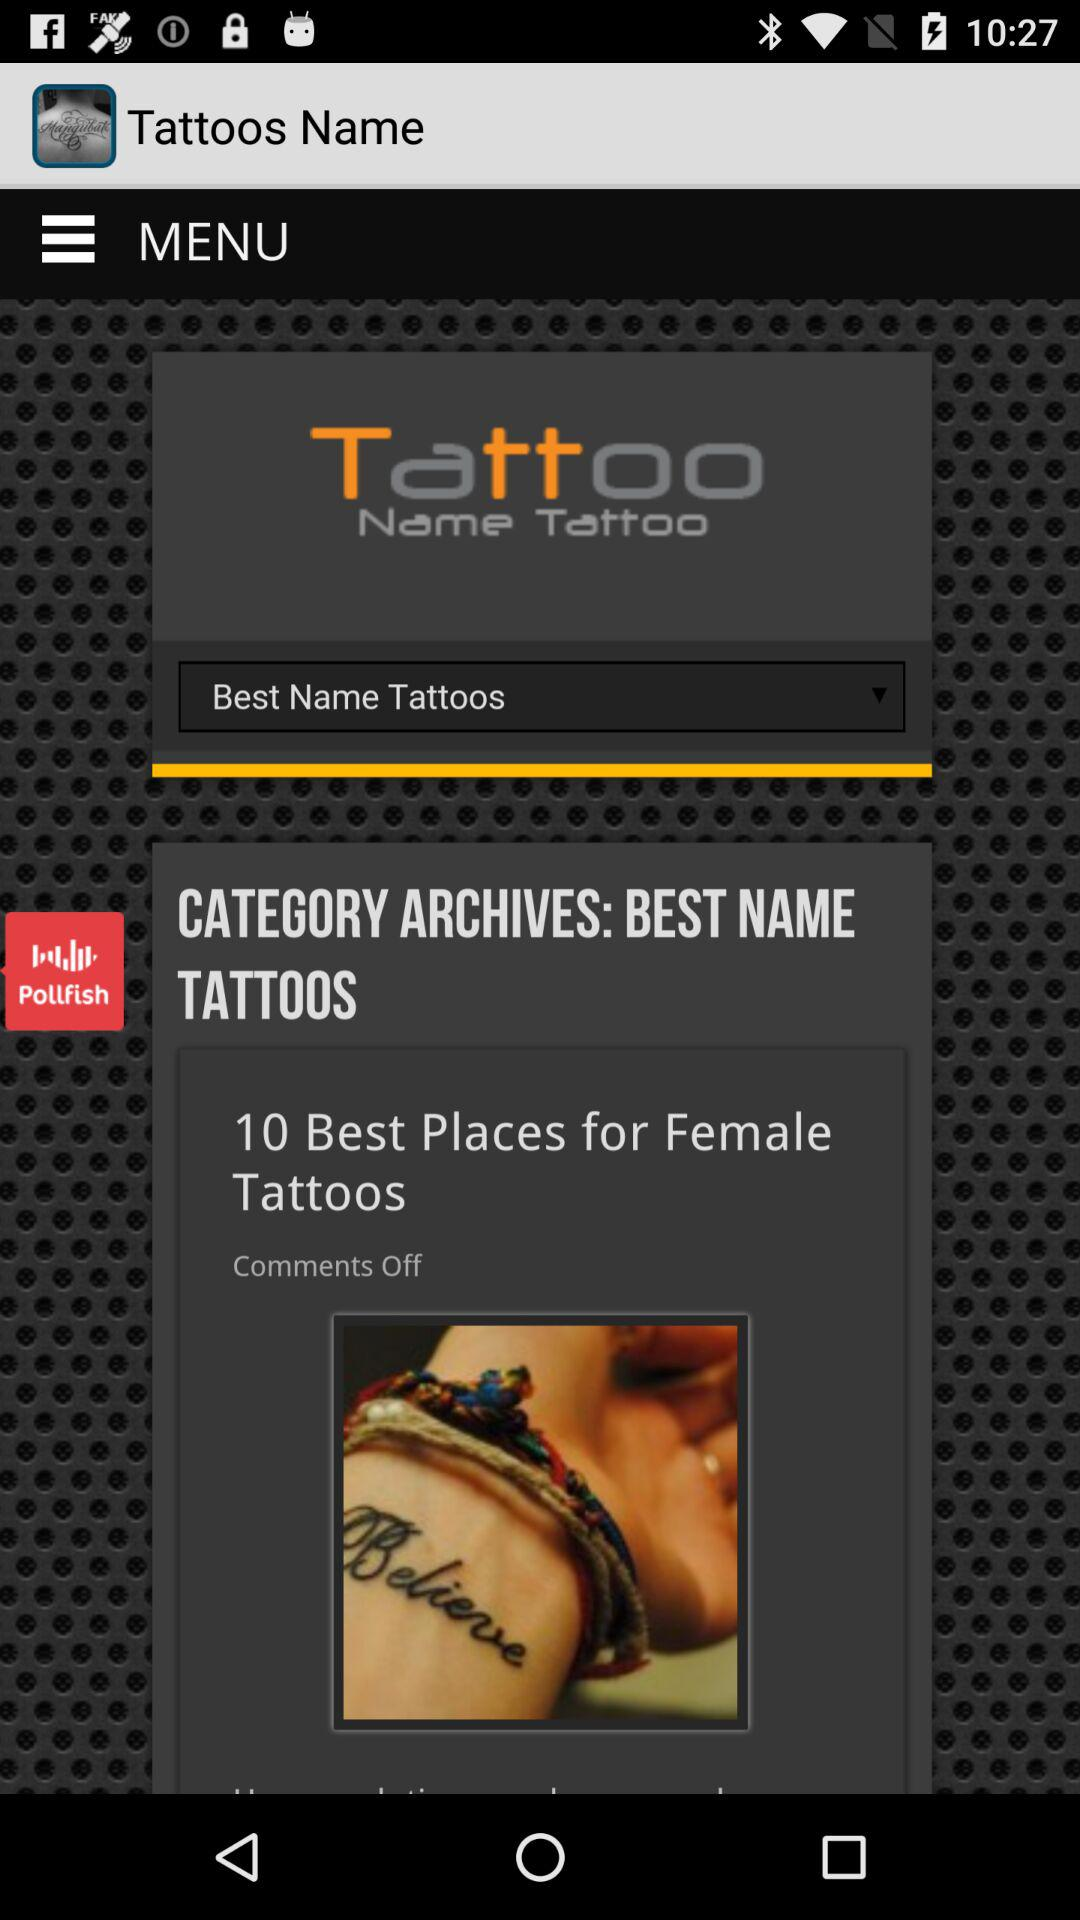Which category of tattoos are selected? The selected category is "Best Name Tattoos". 